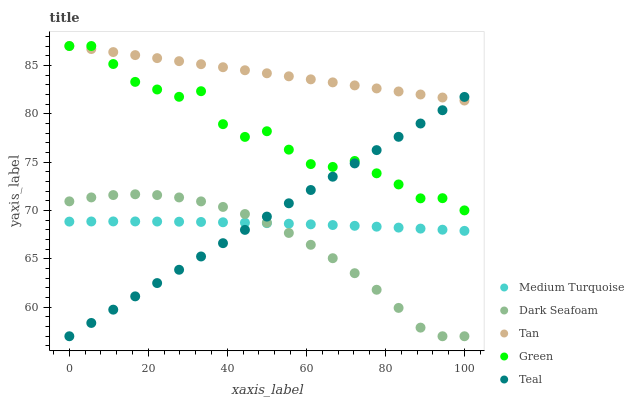Does Dark Seafoam have the minimum area under the curve?
Answer yes or no. Yes. Does Tan have the maximum area under the curve?
Answer yes or no. Yes. Does Green have the minimum area under the curve?
Answer yes or no. No. Does Green have the maximum area under the curve?
Answer yes or no. No. Is Tan the smoothest?
Answer yes or no. Yes. Is Green the roughest?
Answer yes or no. Yes. Is Dark Seafoam the smoothest?
Answer yes or no. No. Is Dark Seafoam the roughest?
Answer yes or no. No. Does Teal have the lowest value?
Answer yes or no. Yes. Does Green have the lowest value?
Answer yes or no. No. Does Tan have the highest value?
Answer yes or no. Yes. Does Dark Seafoam have the highest value?
Answer yes or no. No. Is Dark Seafoam less than Green?
Answer yes or no. Yes. Is Green greater than Dark Seafoam?
Answer yes or no. Yes. Does Teal intersect Dark Seafoam?
Answer yes or no. Yes. Is Teal less than Dark Seafoam?
Answer yes or no. No. Is Teal greater than Dark Seafoam?
Answer yes or no. No. Does Dark Seafoam intersect Green?
Answer yes or no. No. 